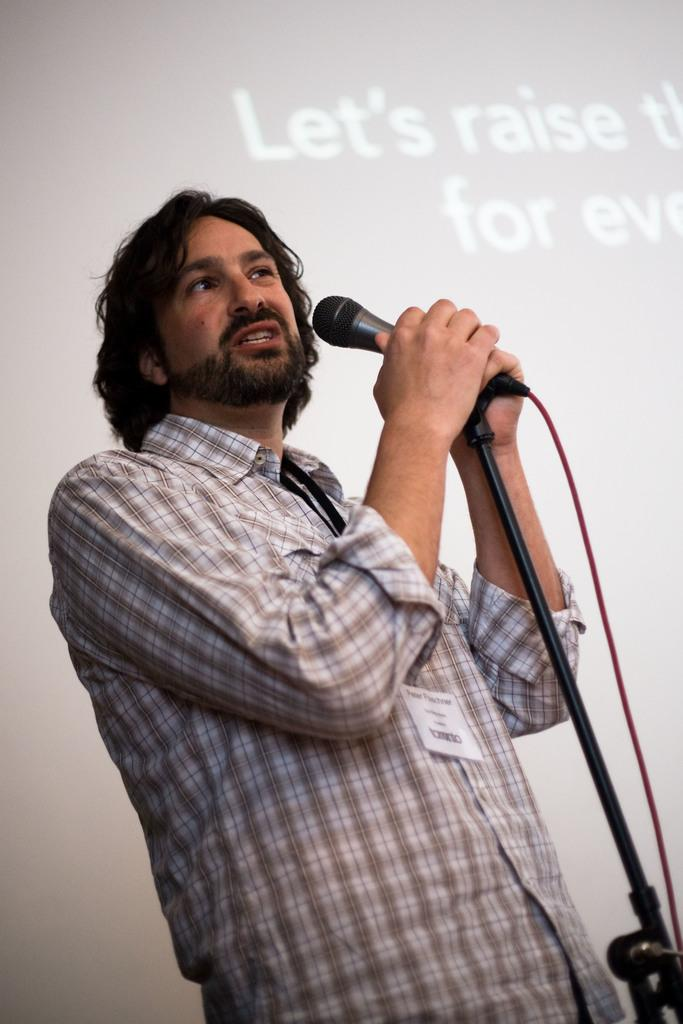What is the man in the image doing? The man is standing in the image and holding a microphone. What is the microphone attached to in the image? The microphone is on a stand. What can be seen in the background of the image? There is a screen in the background of the image. What type of shoe is the man wearing in the image? There is no information about the man's shoes in the image, so we cannot determine the type of shoe he is wearing. How many times does the man sneeze in the image? There is no indication of the man sneezing in the image, so we cannot determine how many times he sneezes. 